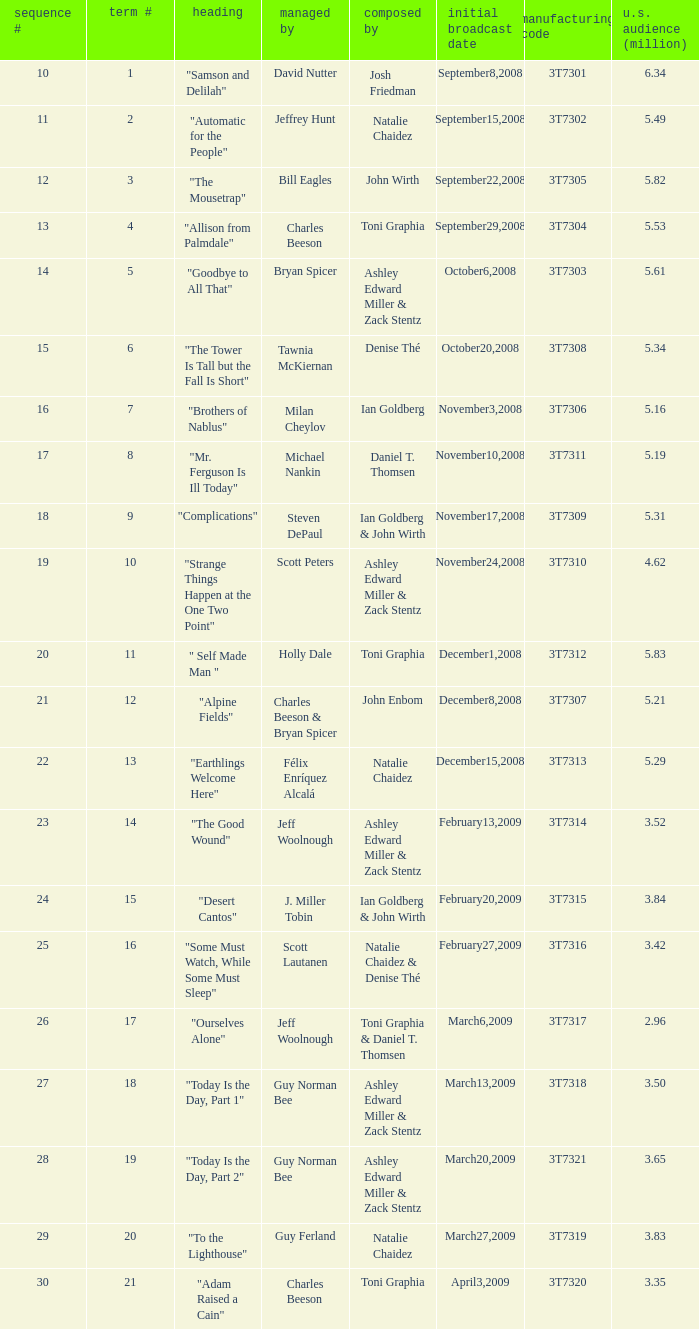How many viewers did the episode directed by David Nutter draw in? 6.34. 